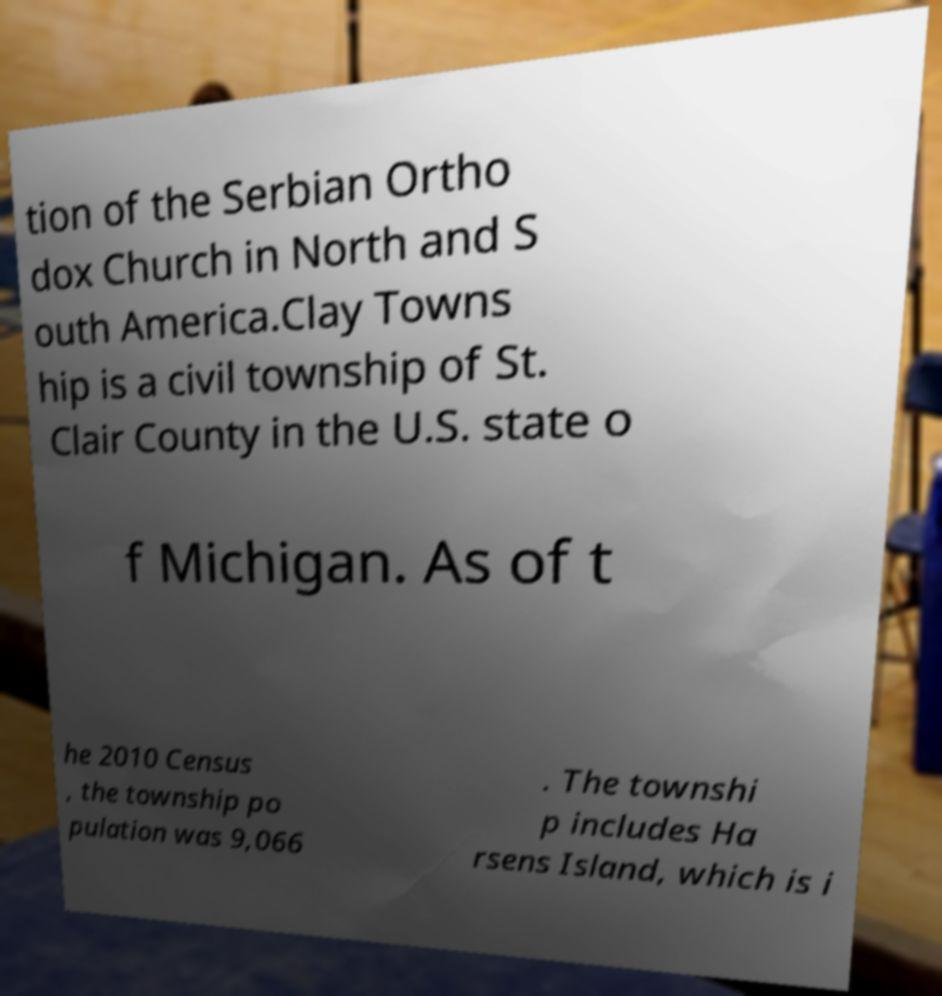Please read and relay the text visible in this image. What does it say? tion of the Serbian Ortho dox Church in North and S outh America.Clay Towns hip is a civil township of St. Clair County in the U.S. state o f Michigan. As of t he 2010 Census , the township po pulation was 9,066 . The townshi p includes Ha rsens Island, which is i 